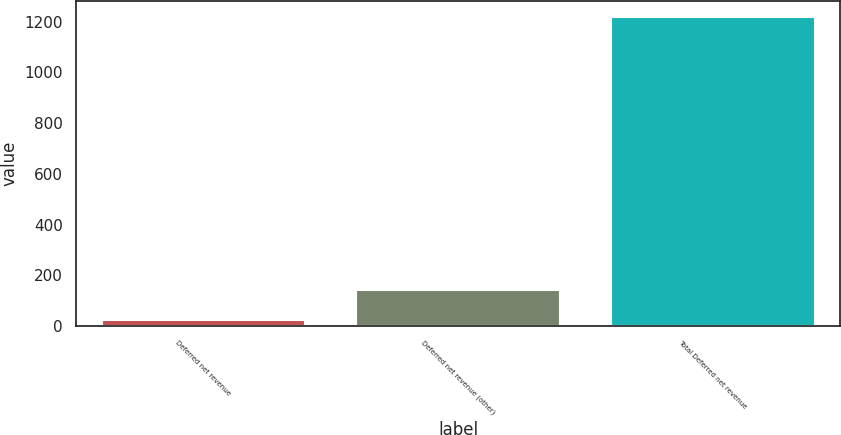Convert chart. <chart><loc_0><loc_0><loc_500><loc_500><bar_chart><fcel>Deferred net revenue<fcel>Deferred net revenue (other)<fcel>Total Deferred net revenue<nl><fcel>23<fcel>142.4<fcel>1219.4<nl></chart> 